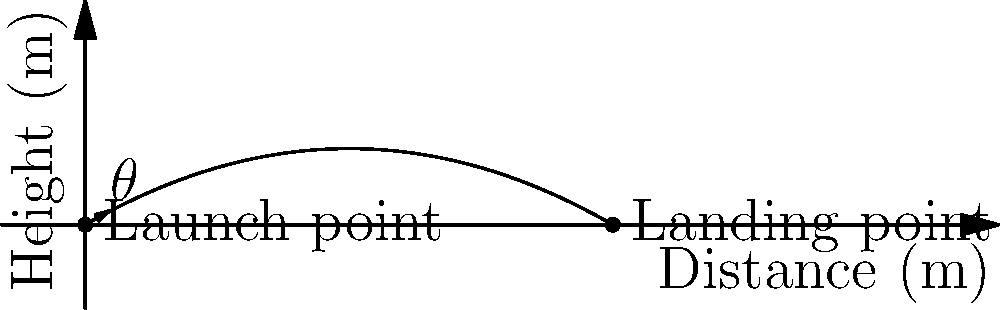During a church picnic, you organize a fundraising event involving a water balloon toss to support the families of deployed officers. A volunteer launches a water balloon at an angle of 30° above the horizontal with an initial velocity of 50 m/s. Assuming air resistance is negligible, what is the maximum horizontal distance the water balloon will travel before landing? Let's approach this step-by-step:

1) The range (R) of a projectile launched at an angle θ with initial velocity v₀ is given by the formula:

   $R = \frac{v_0^2 \sin(2\theta)}{g}$

   Where g is the acceleration due to gravity (9.8 m/s²).

2) We're given:
   - Initial velocity, $v_0 = 50$ m/s
   - Angle, $\theta = 30°$
   - $g = 9.8$ m/s²

3) First, we need to convert the angle to radians:
   $30° = \frac{\pi}{6}$ radians

4) Now, let's calculate $\sin(2\theta)$:
   $\sin(2\theta) = \sin(\frac{\pi}{3}) = \frac{\sqrt{3}}{2}$

5) Substituting these values into our range equation:

   $R = \frac{(50)^2 \cdot \frac{\sqrt{3}}{2}}{9.8}$

6) Simplifying:
   $R = \frac{2500 \cdot \sqrt{3}}{19.6} \approx 220.8$ m

Therefore, the water balloon will travel approximately 220.8 meters horizontally before landing.
Answer: 220.8 meters 